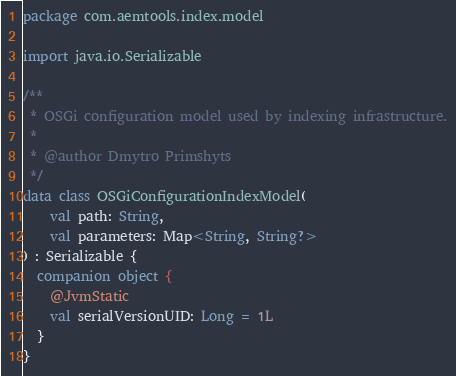Convert code to text. <code><loc_0><loc_0><loc_500><loc_500><_Kotlin_>package com.aemtools.index.model

import java.io.Serializable

/**
 * OSGi configuration model used by indexing infrastructure.
 *
 * @author Dmytro Primshyts
 */
data class OSGiConfigurationIndexModel(
    val path: String,
    val parameters: Map<String, String?>
) : Serializable {
  companion object {
    @JvmStatic
    val serialVersionUID: Long = 1L
  }
}
</code> 